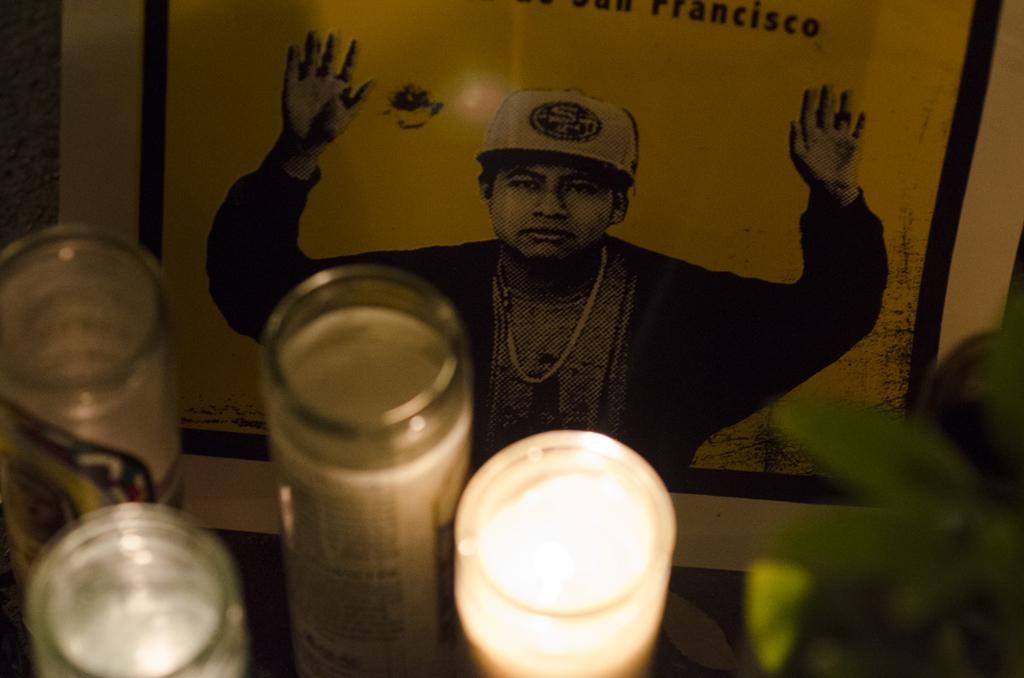What objects are located at the bottom of the image? There are light, glass objects, and leaves at the bottom of the image. What can be seen in the background of the image? There is a poster in the background of the image. What is depicted on the poster? The poster features a person. Are there any words on the poster? Yes, there is text on the poster. Can you tell me how many lakes are visible in the image? There are no lakes visible in the image; it features light, glass objects, leaves, and a poster with a person and text. Is there a cellar shown in the image? There is no cellar present in the image. 